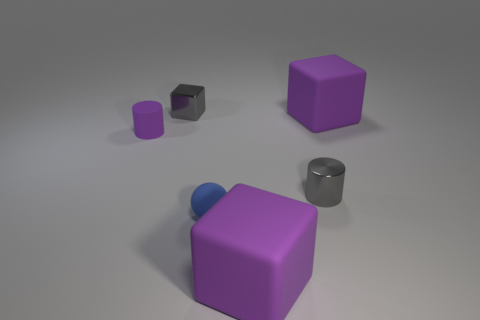Add 2 tiny blue rubber spheres. How many objects exist? 8 Subtract all cylinders. How many objects are left? 4 Subtract all gray objects. Subtract all small blue metal cylinders. How many objects are left? 4 Add 1 large purple matte objects. How many large purple matte objects are left? 3 Add 6 big purple rubber things. How many big purple rubber things exist? 8 Subtract 0 yellow blocks. How many objects are left? 6 